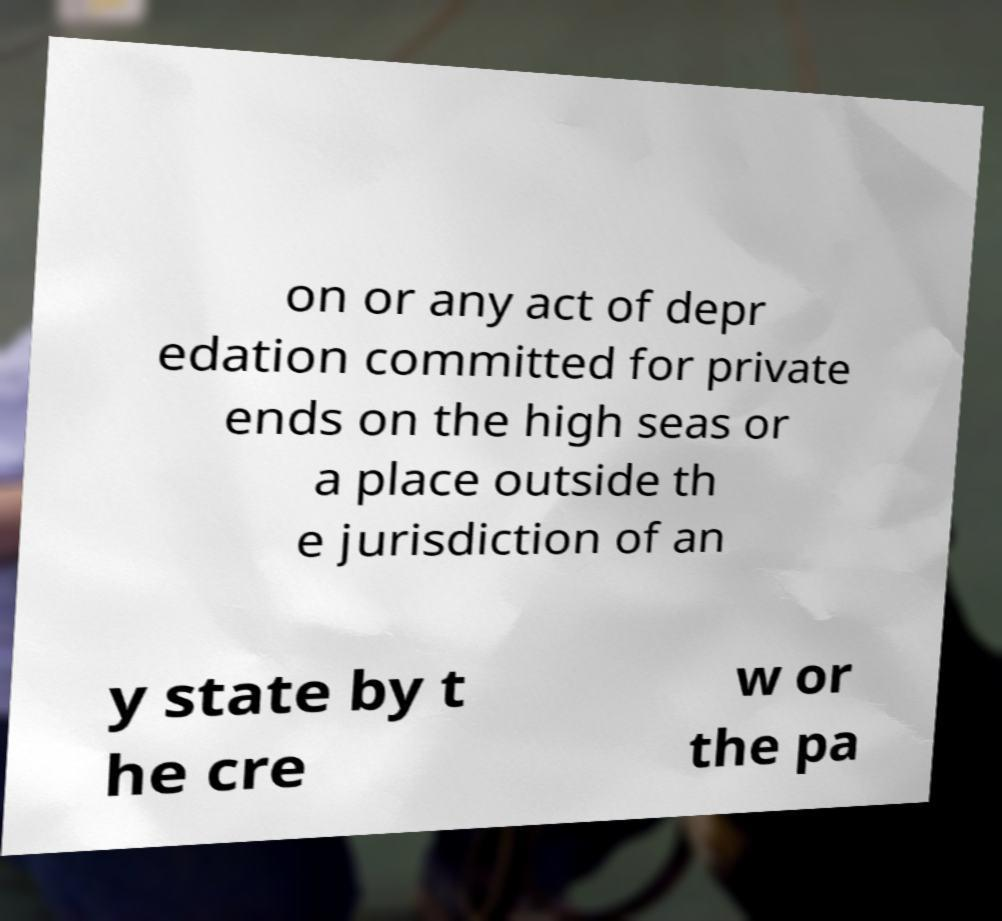Can you accurately transcribe the text from the provided image for me? on or any act of depr edation committed for private ends on the high seas or a place outside th e jurisdiction of an y state by t he cre w or the pa 